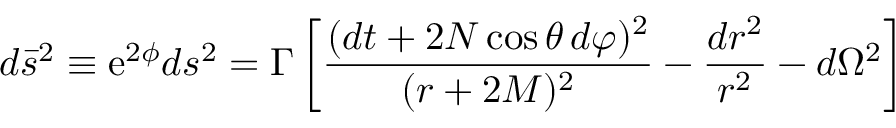Convert formula to latex. <formula><loc_0><loc_0><loc_500><loc_500>d \bar { s } ^ { 2 } \equiv e ^ { 2 \phi } d s ^ { 2 } = \Gamma \left [ \frac { ( d t + 2 N \cos \theta \, d \varphi ) ^ { 2 } } { ( r + 2 M ) ^ { 2 } } - \frac { d r ^ { 2 } } { r ^ { 2 } } - d \Omega ^ { 2 } \right ]</formula> 